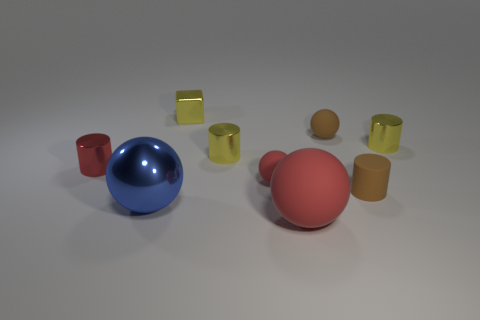Is there any other thing that has the same material as the brown ball?
Your response must be concise. Yes. The tiny rubber cylinder is what color?
Your response must be concise. Brown. There is a metallic object that is the same color as the big rubber sphere; what is its shape?
Your answer should be compact. Cylinder. There is another rubber ball that is the same size as the blue ball; what is its color?
Your answer should be very brief. Red. How many rubber things are either spheres or tiny purple cylinders?
Give a very brief answer. 3. What number of tiny metal things are in front of the block and on the right side of the red cylinder?
Keep it short and to the point. 2. What number of other things are the same size as the brown matte cylinder?
Ensure brevity in your answer.  6. Is the size of the red ball on the left side of the big rubber thing the same as the cylinder that is left of the tiny metal block?
Your answer should be compact. Yes. How many things are big balls or rubber things behind the big blue ball?
Make the answer very short. 5. There is a matte ball in front of the blue sphere; how big is it?
Your answer should be very brief. Large. 